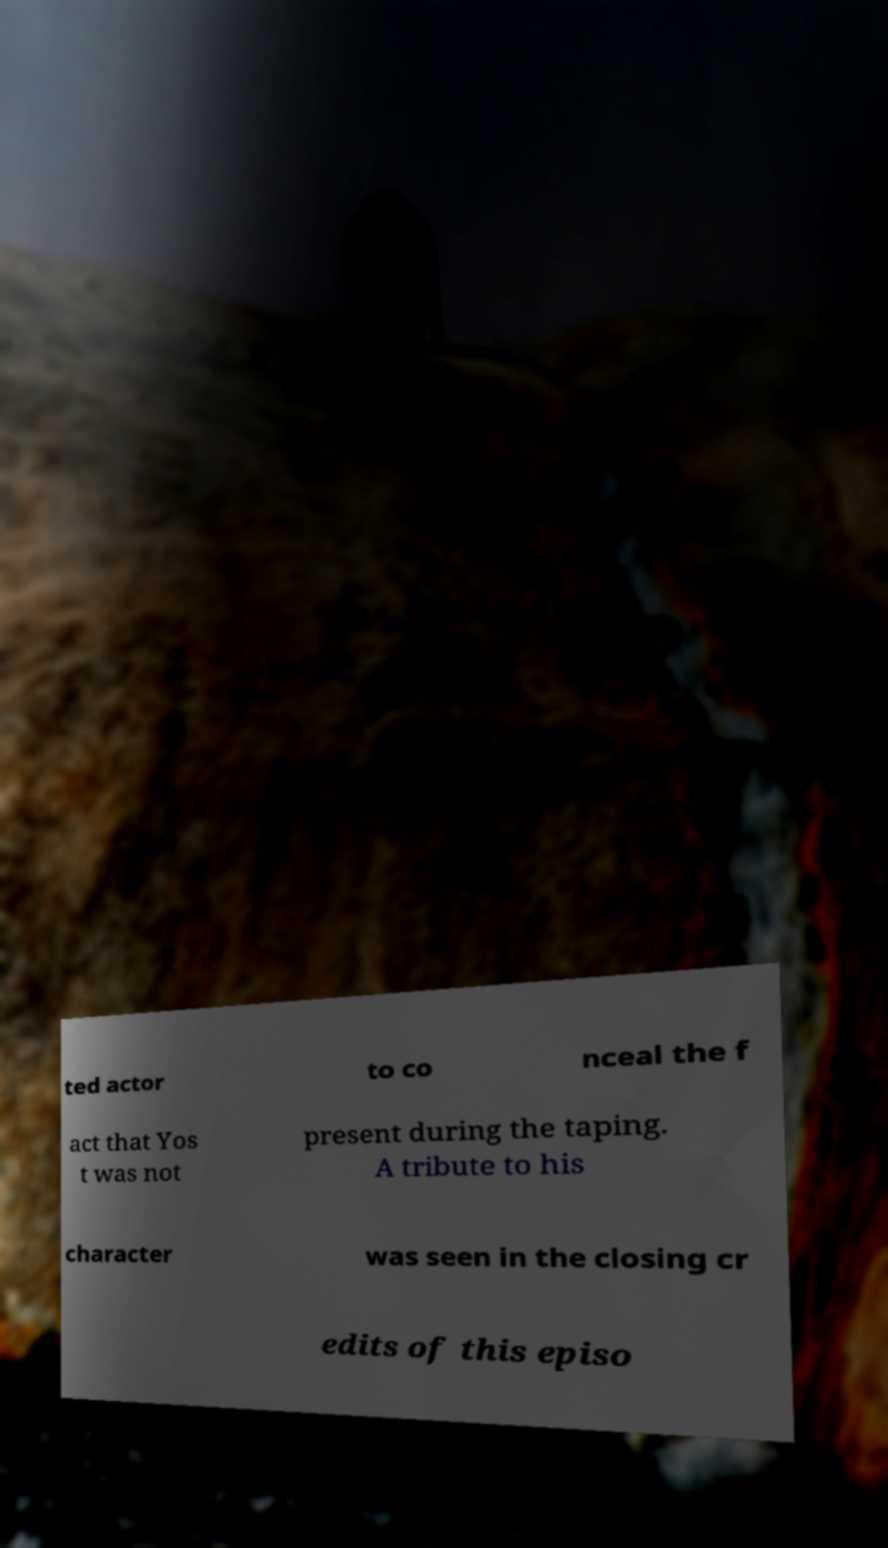Please read and relay the text visible in this image. What does it say? ted actor to co nceal the f act that Yos t was not present during the taping. A tribute to his character was seen in the closing cr edits of this episo 